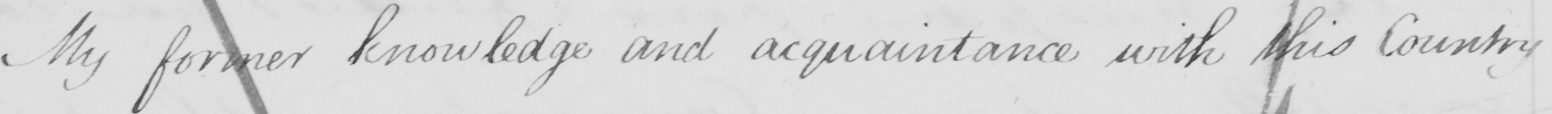Can you tell me what this handwritten text says? My former knowledge and acquaintance with this Country 